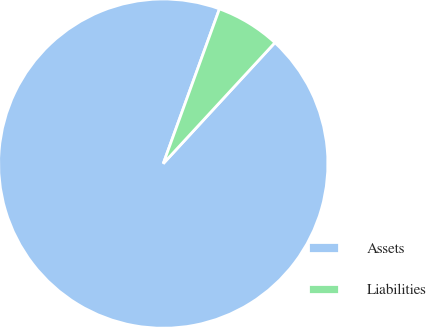<chart> <loc_0><loc_0><loc_500><loc_500><pie_chart><fcel>Assets<fcel>Liabilities<nl><fcel>93.68%<fcel>6.32%<nl></chart> 